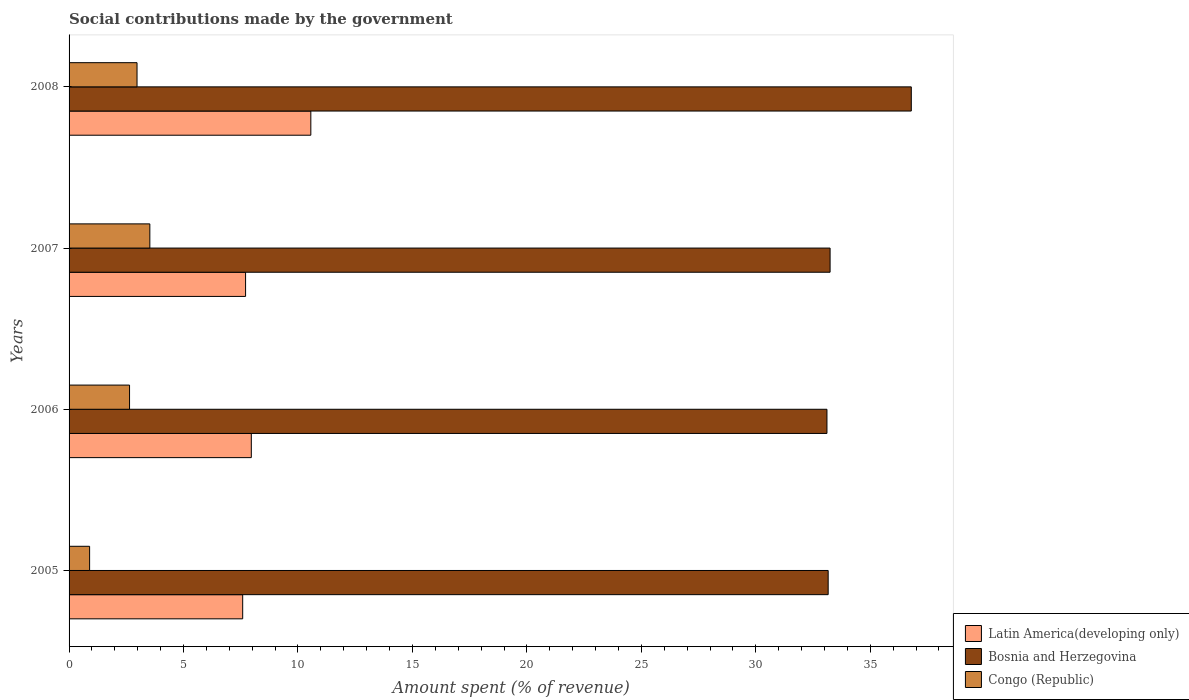How many different coloured bars are there?
Provide a short and direct response. 3. How many groups of bars are there?
Give a very brief answer. 4. Are the number of bars per tick equal to the number of legend labels?
Your response must be concise. Yes. What is the amount spent (in %) on social contributions in Latin America(developing only) in 2007?
Your answer should be very brief. 7.71. Across all years, what is the maximum amount spent (in %) on social contributions in Bosnia and Herzegovina?
Offer a very short reply. 36.79. Across all years, what is the minimum amount spent (in %) on social contributions in Latin America(developing only)?
Offer a very short reply. 7.58. In which year was the amount spent (in %) on social contributions in Latin America(developing only) maximum?
Offer a terse response. 2008. What is the total amount spent (in %) on social contributions in Bosnia and Herzegovina in the graph?
Provide a short and direct response. 136.31. What is the difference between the amount spent (in %) on social contributions in Bosnia and Herzegovina in 2006 and that in 2008?
Your answer should be very brief. -3.69. What is the difference between the amount spent (in %) on social contributions in Latin America(developing only) in 2006 and the amount spent (in %) on social contributions in Bosnia and Herzegovina in 2007?
Ensure brevity in your answer.  -25.28. What is the average amount spent (in %) on social contributions in Latin America(developing only) per year?
Make the answer very short. 8.45. In the year 2008, what is the difference between the amount spent (in %) on social contributions in Bosnia and Herzegovina and amount spent (in %) on social contributions in Latin America(developing only)?
Make the answer very short. 26.23. In how many years, is the amount spent (in %) on social contributions in Bosnia and Herzegovina greater than 37 %?
Give a very brief answer. 0. What is the ratio of the amount spent (in %) on social contributions in Congo (Republic) in 2005 to that in 2006?
Provide a succinct answer. 0.34. Is the amount spent (in %) on social contributions in Latin America(developing only) in 2006 less than that in 2008?
Ensure brevity in your answer.  Yes. What is the difference between the highest and the second highest amount spent (in %) on social contributions in Bosnia and Herzegovina?
Give a very brief answer. 3.55. What is the difference between the highest and the lowest amount spent (in %) on social contributions in Latin America(developing only)?
Your answer should be very brief. 2.98. In how many years, is the amount spent (in %) on social contributions in Bosnia and Herzegovina greater than the average amount spent (in %) on social contributions in Bosnia and Herzegovina taken over all years?
Make the answer very short. 1. Is the sum of the amount spent (in %) on social contributions in Congo (Republic) in 2006 and 2007 greater than the maximum amount spent (in %) on social contributions in Latin America(developing only) across all years?
Provide a short and direct response. No. What does the 1st bar from the top in 2008 represents?
Ensure brevity in your answer.  Congo (Republic). What does the 2nd bar from the bottom in 2006 represents?
Your response must be concise. Bosnia and Herzegovina. Is it the case that in every year, the sum of the amount spent (in %) on social contributions in Latin America(developing only) and amount spent (in %) on social contributions in Bosnia and Herzegovina is greater than the amount spent (in %) on social contributions in Congo (Republic)?
Make the answer very short. Yes. How many bars are there?
Ensure brevity in your answer.  12. How many years are there in the graph?
Offer a terse response. 4. Are the values on the major ticks of X-axis written in scientific E-notation?
Your response must be concise. No. Does the graph contain grids?
Your answer should be compact. No. How many legend labels are there?
Ensure brevity in your answer.  3. What is the title of the graph?
Provide a short and direct response. Social contributions made by the government. What is the label or title of the X-axis?
Offer a terse response. Amount spent (% of revenue). What is the Amount spent (% of revenue) in Latin America(developing only) in 2005?
Ensure brevity in your answer.  7.58. What is the Amount spent (% of revenue) in Bosnia and Herzegovina in 2005?
Your answer should be compact. 33.16. What is the Amount spent (% of revenue) of Congo (Republic) in 2005?
Offer a very short reply. 0.9. What is the Amount spent (% of revenue) of Latin America(developing only) in 2006?
Give a very brief answer. 7.96. What is the Amount spent (% of revenue) in Bosnia and Herzegovina in 2006?
Keep it short and to the point. 33.11. What is the Amount spent (% of revenue) in Congo (Republic) in 2006?
Keep it short and to the point. 2.64. What is the Amount spent (% of revenue) of Latin America(developing only) in 2007?
Provide a succinct answer. 7.71. What is the Amount spent (% of revenue) in Bosnia and Herzegovina in 2007?
Provide a succinct answer. 33.25. What is the Amount spent (% of revenue) in Congo (Republic) in 2007?
Provide a succinct answer. 3.53. What is the Amount spent (% of revenue) in Latin America(developing only) in 2008?
Offer a very short reply. 10.56. What is the Amount spent (% of revenue) of Bosnia and Herzegovina in 2008?
Offer a terse response. 36.79. What is the Amount spent (% of revenue) in Congo (Republic) in 2008?
Offer a terse response. 2.97. Across all years, what is the maximum Amount spent (% of revenue) of Latin America(developing only)?
Your answer should be very brief. 10.56. Across all years, what is the maximum Amount spent (% of revenue) in Bosnia and Herzegovina?
Give a very brief answer. 36.79. Across all years, what is the maximum Amount spent (% of revenue) in Congo (Republic)?
Provide a succinct answer. 3.53. Across all years, what is the minimum Amount spent (% of revenue) of Latin America(developing only)?
Keep it short and to the point. 7.58. Across all years, what is the minimum Amount spent (% of revenue) in Bosnia and Herzegovina?
Offer a terse response. 33.11. Across all years, what is the minimum Amount spent (% of revenue) in Congo (Republic)?
Provide a succinct answer. 0.9. What is the total Amount spent (% of revenue) in Latin America(developing only) in the graph?
Keep it short and to the point. 33.82. What is the total Amount spent (% of revenue) of Bosnia and Herzegovina in the graph?
Give a very brief answer. 136.31. What is the total Amount spent (% of revenue) in Congo (Republic) in the graph?
Ensure brevity in your answer.  10.04. What is the difference between the Amount spent (% of revenue) of Latin America(developing only) in 2005 and that in 2006?
Your answer should be very brief. -0.38. What is the difference between the Amount spent (% of revenue) in Bosnia and Herzegovina in 2005 and that in 2006?
Give a very brief answer. 0.05. What is the difference between the Amount spent (% of revenue) in Congo (Republic) in 2005 and that in 2006?
Keep it short and to the point. -1.74. What is the difference between the Amount spent (% of revenue) in Latin America(developing only) in 2005 and that in 2007?
Make the answer very short. -0.13. What is the difference between the Amount spent (% of revenue) in Bosnia and Herzegovina in 2005 and that in 2007?
Ensure brevity in your answer.  -0.08. What is the difference between the Amount spent (% of revenue) of Congo (Republic) in 2005 and that in 2007?
Your response must be concise. -2.63. What is the difference between the Amount spent (% of revenue) of Latin America(developing only) in 2005 and that in 2008?
Make the answer very short. -2.98. What is the difference between the Amount spent (% of revenue) in Bosnia and Herzegovina in 2005 and that in 2008?
Your answer should be compact. -3.63. What is the difference between the Amount spent (% of revenue) in Congo (Republic) in 2005 and that in 2008?
Provide a short and direct response. -2.07. What is the difference between the Amount spent (% of revenue) of Latin America(developing only) in 2006 and that in 2007?
Your answer should be compact. 0.25. What is the difference between the Amount spent (% of revenue) of Bosnia and Herzegovina in 2006 and that in 2007?
Provide a succinct answer. -0.14. What is the difference between the Amount spent (% of revenue) in Congo (Republic) in 2006 and that in 2007?
Make the answer very short. -0.89. What is the difference between the Amount spent (% of revenue) of Latin America(developing only) in 2006 and that in 2008?
Make the answer very short. -2.6. What is the difference between the Amount spent (% of revenue) in Bosnia and Herzegovina in 2006 and that in 2008?
Ensure brevity in your answer.  -3.69. What is the difference between the Amount spent (% of revenue) of Congo (Republic) in 2006 and that in 2008?
Offer a very short reply. -0.33. What is the difference between the Amount spent (% of revenue) in Latin America(developing only) in 2007 and that in 2008?
Make the answer very short. -2.85. What is the difference between the Amount spent (% of revenue) of Bosnia and Herzegovina in 2007 and that in 2008?
Your answer should be compact. -3.55. What is the difference between the Amount spent (% of revenue) in Congo (Republic) in 2007 and that in 2008?
Your answer should be very brief. 0.56. What is the difference between the Amount spent (% of revenue) of Latin America(developing only) in 2005 and the Amount spent (% of revenue) of Bosnia and Herzegovina in 2006?
Offer a very short reply. -25.52. What is the difference between the Amount spent (% of revenue) in Latin America(developing only) in 2005 and the Amount spent (% of revenue) in Congo (Republic) in 2006?
Offer a terse response. 4.94. What is the difference between the Amount spent (% of revenue) in Bosnia and Herzegovina in 2005 and the Amount spent (% of revenue) in Congo (Republic) in 2006?
Offer a very short reply. 30.52. What is the difference between the Amount spent (% of revenue) of Latin America(developing only) in 2005 and the Amount spent (% of revenue) of Bosnia and Herzegovina in 2007?
Provide a short and direct response. -25.66. What is the difference between the Amount spent (% of revenue) in Latin America(developing only) in 2005 and the Amount spent (% of revenue) in Congo (Republic) in 2007?
Your answer should be compact. 4.06. What is the difference between the Amount spent (% of revenue) of Bosnia and Herzegovina in 2005 and the Amount spent (% of revenue) of Congo (Republic) in 2007?
Make the answer very short. 29.63. What is the difference between the Amount spent (% of revenue) of Latin America(developing only) in 2005 and the Amount spent (% of revenue) of Bosnia and Herzegovina in 2008?
Ensure brevity in your answer.  -29.21. What is the difference between the Amount spent (% of revenue) of Latin America(developing only) in 2005 and the Amount spent (% of revenue) of Congo (Republic) in 2008?
Keep it short and to the point. 4.62. What is the difference between the Amount spent (% of revenue) of Bosnia and Herzegovina in 2005 and the Amount spent (% of revenue) of Congo (Republic) in 2008?
Make the answer very short. 30.19. What is the difference between the Amount spent (% of revenue) of Latin America(developing only) in 2006 and the Amount spent (% of revenue) of Bosnia and Herzegovina in 2007?
Your answer should be compact. -25.28. What is the difference between the Amount spent (% of revenue) in Latin America(developing only) in 2006 and the Amount spent (% of revenue) in Congo (Republic) in 2007?
Offer a very short reply. 4.43. What is the difference between the Amount spent (% of revenue) in Bosnia and Herzegovina in 2006 and the Amount spent (% of revenue) in Congo (Republic) in 2007?
Your answer should be compact. 29.58. What is the difference between the Amount spent (% of revenue) of Latin America(developing only) in 2006 and the Amount spent (% of revenue) of Bosnia and Herzegovina in 2008?
Make the answer very short. -28.83. What is the difference between the Amount spent (% of revenue) in Latin America(developing only) in 2006 and the Amount spent (% of revenue) in Congo (Republic) in 2008?
Provide a short and direct response. 4.99. What is the difference between the Amount spent (% of revenue) in Bosnia and Herzegovina in 2006 and the Amount spent (% of revenue) in Congo (Republic) in 2008?
Make the answer very short. 30.14. What is the difference between the Amount spent (% of revenue) in Latin America(developing only) in 2007 and the Amount spent (% of revenue) in Bosnia and Herzegovina in 2008?
Your answer should be compact. -29.08. What is the difference between the Amount spent (% of revenue) in Latin America(developing only) in 2007 and the Amount spent (% of revenue) in Congo (Republic) in 2008?
Ensure brevity in your answer.  4.74. What is the difference between the Amount spent (% of revenue) in Bosnia and Herzegovina in 2007 and the Amount spent (% of revenue) in Congo (Republic) in 2008?
Provide a short and direct response. 30.28. What is the average Amount spent (% of revenue) in Latin America(developing only) per year?
Provide a succinct answer. 8.45. What is the average Amount spent (% of revenue) of Bosnia and Herzegovina per year?
Provide a succinct answer. 34.08. What is the average Amount spent (% of revenue) of Congo (Republic) per year?
Give a very brief answer. 2.51. In the year 2005, what is the difference between the Amount spent (% of revenue) of Latin America(developing only) and Amount spent (% of revenue) of Bosnia and Herzegovina?
Your response must be concise. -25.58. In the year 2005, what is the difference between the Amount spent (% of revenue) of Latin America(developing only) and Amount spent (% of revenue) of Congo (Republic)?
Your answer should be compact. 6.69. In the year 2005, what is the difference between the Amount spent (% of revenue) of Bosnia and Herzegovina and Amount spent (% of revenue) of Congo (Republic)?
Keep it short and to the point. 32.26. In the year 2006, what is the difference between the Amount spent (% of revenue) in Latin America(developing only) and Amount spent (% of revenue) in Bosnia and Herzegovina?
Give a very brief answer. -25.15. In the year 2006, what is the difference between the Amount spent (% of revenue) in Latin America(developing only) and Amount spent (% of revenue) in Congo (Republic)?
Make the answer very short. 5.32. In the year 2006, what is the difference between the Amount spent (% of revenue) in Bosnia and Herzegovina and Amount spent (% of revenue) in Congo (Republic)?
Your response must be concise. 30.47. In the year 2007, what is the difference between the Amount spent (% of revenue) of Latin America(developing only) and Amount spent (% of revenue) of Bosnia and Herzegovina?
Offer a terse response. -25.53. In the year 2007, what is the difference between the Amount spent (% of revenue) of Latin America(developing only) and Amount spent (% of revenue) of Congo (Republic)?
Provide a succinct answer. 4.18. In the year 2007, what is the difference between the Amount spent (% of revenue) of Bosnia and Herzegovina and Amount spent (% of revenue) of Congo (Republic)?
Provide a succinct answer. 29.72. In the year 2008, what is the difference between the Amount spent (% of revenue) in Latin America(developing only) and Amount spent (% of revenue) in Bosnia and Herzegovina?
Your response must be concise. -26.23. In the year 2008, what is the difference between the Amount spent (% of revenue) in Latin America(developing only) and Amount spent (% of revenue) in Congo (Republic)?
Your response must be concise. 7.59. In the year 2008, what is the difference between the Amount spent (% of revenue) of Bosnia and Herzegovina and Amount spent (% of revenue) of Congo (Republic)?
Your response must be concise. 33.82. What is the ratio of the Amount spent (% of revenue) of Latin America(developing only) in 2005 to that in 2006?
Your answer should be compact. 0.95. What is the ratio of the Amount spent (% of revenue) in Congo (Republic) in 2005 to that in 2006?
Give a very brief answer. 0.34. What is the ratio of the Amount spent (% of revenue) of Latin America(developing only) in 2005 to that in 2007?
Keep it short and to the point. 0.98. What is the ratio of the Amount spent (% of revenue) in Congo (Republic) in 2005 to that in 2007?
Give a very brief answer. 0.25. What is the ratio of the Amount spent (% of revenue) of Latin America(developing only) in 2005 to that in 2008?
Your answer should be compact. 0.72. What is the ratio of the Amount spent (% of revenue) in Bosnia and Herzegovina in 2005 to that in 2008?
Your answer should be compact. 0.9. What is the ratio of the Amount spent (% of revenue) in Congo (Republic) in 2005 to that in 2008?
Make the answer very short. 0.3. What is the ratio of the Amount spent (% of revenue) of Latin America(developing only) in 2006 to that in 2007?
Your answer should be very brief. 1.03. What is the ratio of the Amount spent (% of revenue) in Bosnia and Herzegovina in 2006 to that in 2007?
Ensure brevity in your answer.  1. What is the ratio of the Amount spent (% of revenue) in Congo (Republic) in 2006 to that in 2007?
Offer a terse response. 0.75. What is the ratio of the Amount spent (% of revenue) in Latin America(developing only) in 2006 to that in 2008?
Offer a terse response. 0.75. What is the ratio of the Amount spent (% of revenue) in Bosnia and Herzegovina in 2006 to that in 2008?
Provide a short and direct response. 0.9. What is the ratio of the Amount spent (% of revenue) in Congo (Republic) in 2006 to that in 2008?
Your response must be concise. 0.89. What is the ratio of the Amount spent (% of revenue) in Latin America(developing only) in 2007 to that in 2008?
Offer a very short reply. 0.73. What is the ratio of the Amount spent (% of revenue) of Bosnia and Herzegovina in 2007 to that in 2008?
Your answer should be very brief. 0.9. What is the ratio of the Amount spent (% of revenue) in Congo (Republic) in 2007 to that in 2008?
Your response must be concise. 1.19. What is the difference between the highest and the second highest Amount spent (% of revenue) of Latin America(developing only)?
Your answer should be compact. 2.6. What is the difference between the highest and the second highest Amount spent (% of revenue) of Bosnia and Herzegovina?
Give a very brief answer. 3.55. What is the difference between the highest and the second highest Amount spent (% of revenue) in Congo (Republic)?
Provide a succinct answer. 0.56. What is the difference between the highest and the lowest Amount spent (% of revenue) of Latin America(developing only)?
Your response must be concise. 2.98. What is the difference between the highest and the lowest Amount spent (% of revenue) in Bosnia and Herzegovina?
Make the answer very short. 3.69. What is the difference between the highest and the lowest Amount spent (% of revenue) of Congo (Republic)?
Ensure brevity in your answer.  2.63. 